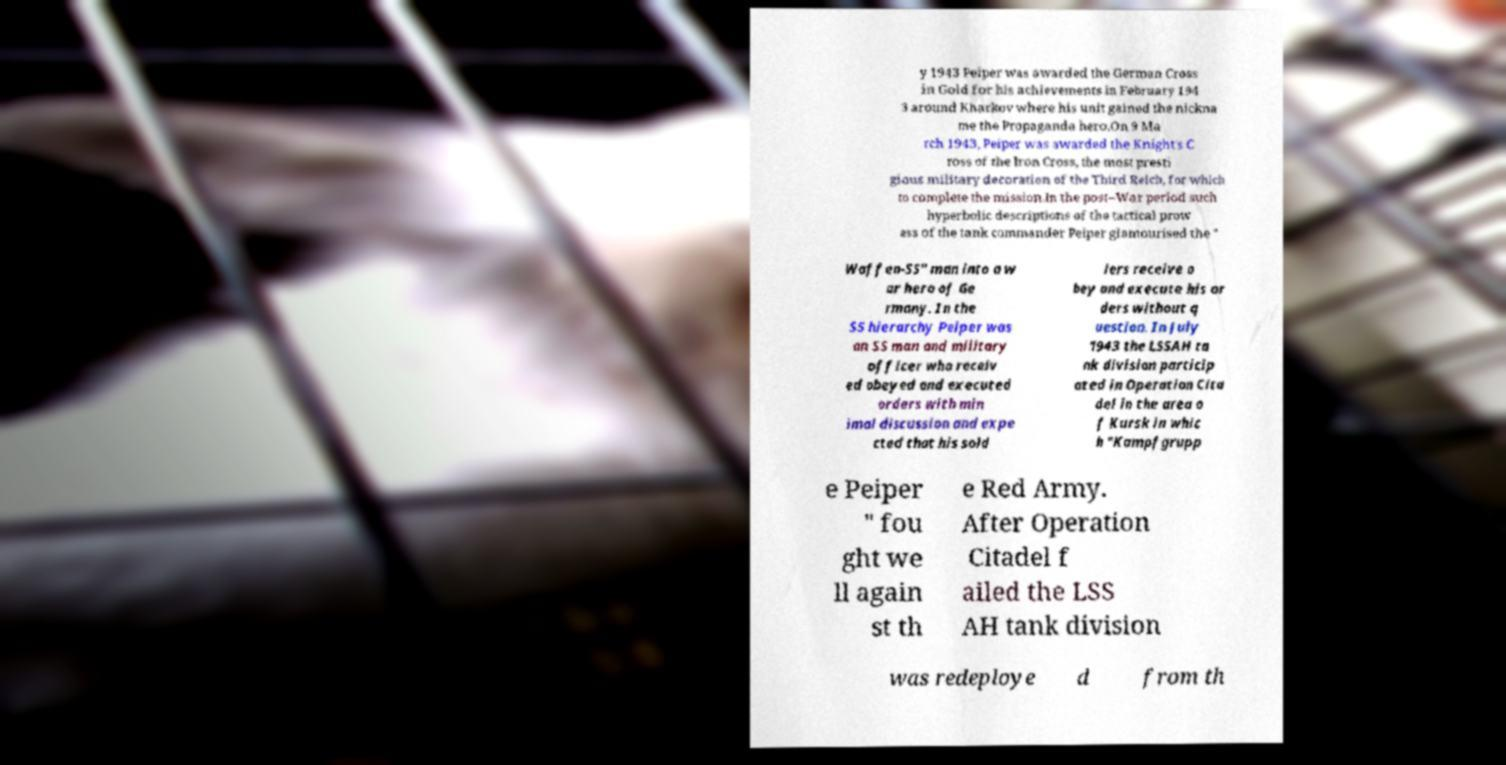Please identify and transcribe the text found in this image. y 1943 Peiper was awarded the German Cross in Gold for his achievements in February 194 3 around Kharkov where his unit gained the nickna me the Propaganda hero.On 9 Ma rch 1943, Peiper was awarded the Knight's C ross of the Iron Cross, the most presti gious military decoration of the Third Reich, for which to complete the mission.In the post–War period such hyperbolic descriptions of the tactical prow ess of the tank commander Peiper glamourised the " Waffen-SS" man into a w ar hero of Ge rmany. In the SS hierarchy Peiper was an SS man and military officer who receiv ed obeyed and executed orders with min imal discussion and expe cted that his sold iers receive o bey and execute his or ders without q uestion. In July 1943 the LSSAH ta nk division particip ated in Operation Cita del in the area o f Kursk in whic h "Kampfgrupp e Peiper " fou ght we ll again st th e Red Army. After Operation Citadel f ailed the LSS AH tank division was redeploye d from th 